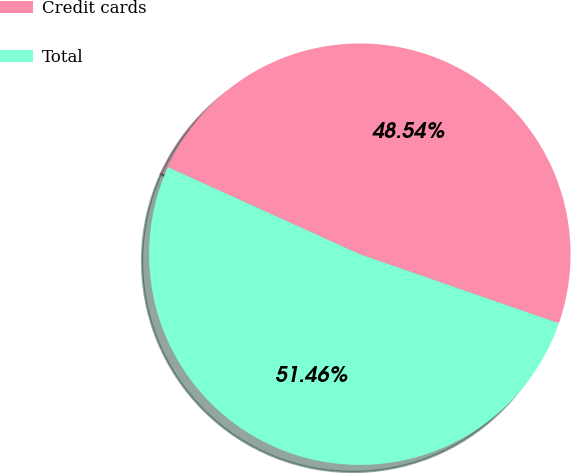Convert chart. <chart><loc_0><loc_0><loc_500><loc_500><pie_chart><fcel>Credit cards<fcel>Total<nl><fcel>48.54%<fcel>51.46%<nl></chart> 